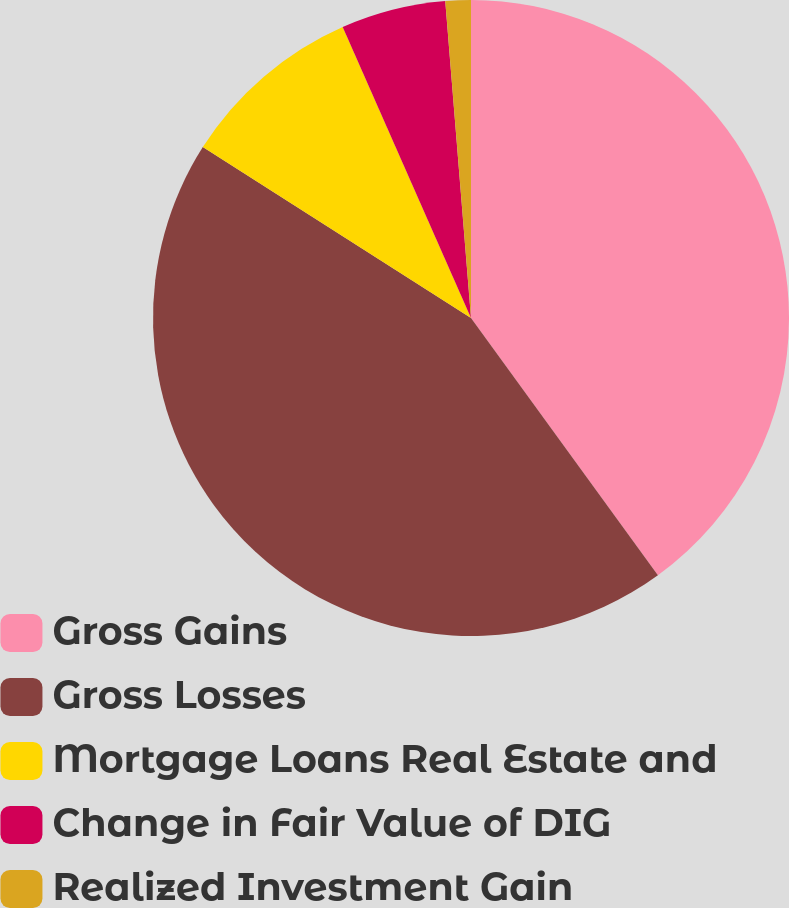<chart> <loc_0><loc_0><loc_500><loc_500><pie_chart><fcel>Gross Gains<fcel>Gross Losses<fcel>Mortgage Loans Real Estate and<fcel>Change in Fair Value of DIG<fcel>Realized Investment Gain<nl><fcel>40.0%<fcel>44.03%<fcel>9.36%<fcel>5.32%<fcel>1.29%<nl></chart> 